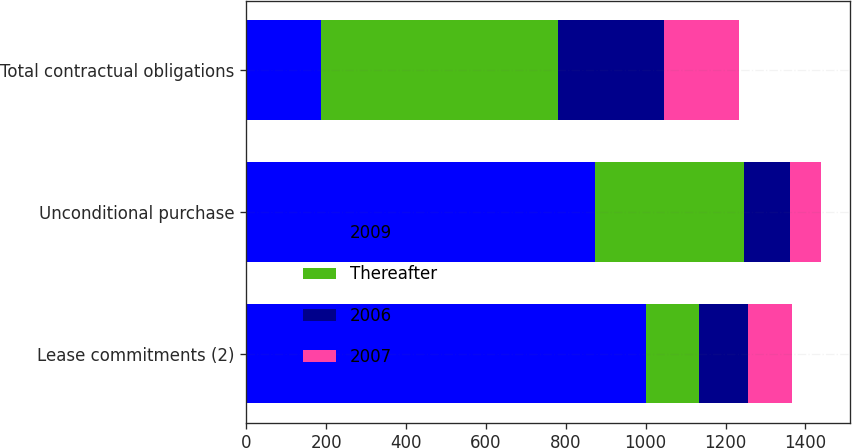<chart> <loc_0><loc_0><loc_500><loc_500><stacked_bar_chart><ecel><fcel>Lease commitments (2)<fcel>Unconditional purchase<fcel>Total contractual obligations<nl><fcel>2009<fcel>1001.9<fcel>873.7<fcel>186.3<nl><fcel>Thereafter<fcel>132.8<fcel>372.8<fcel>595.5<nl><fcel>2006<fcel>122.5<fcel>115<fcel>265.1<nl><fcel>2007<fcel>108.9<fcel>77.4<fcel>186.3<nl></chart> 